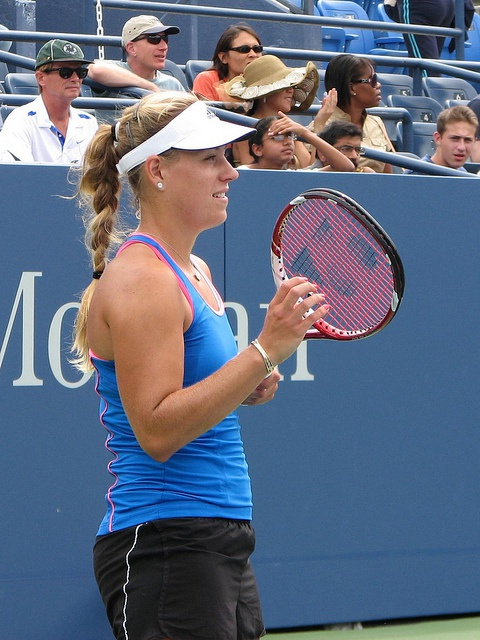Describe the objects in this image and their specific colors. I can see people in blue, black, and salmon tones, tennis racket in blue, gray, brown, and lightpink tones, people in blue, white, brown, gray, and black tones, people in blue, brown, black, maroon, and tan tones, and people in blue, lightgray, brown, lightpink, and black tones in this image. 